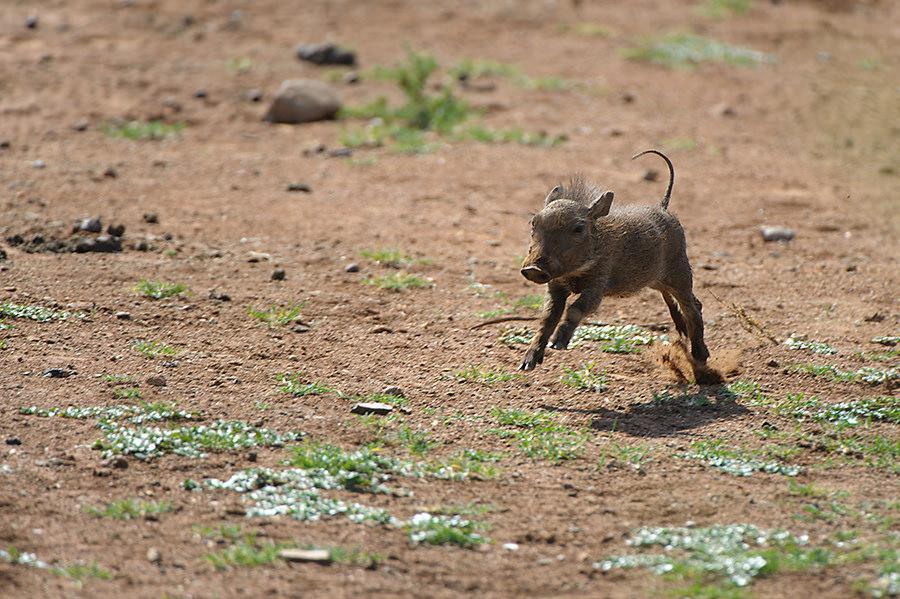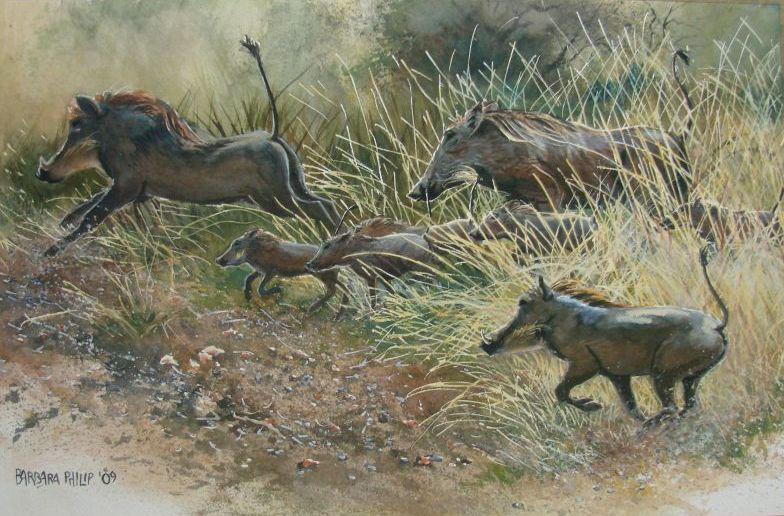The first image is the image on the left, the second image is the image on the right. Examine the images to the left and right. Is the description "There is exactly one animal in the image on the left." accurate? Answer yes or no. Yes. The first image is the image on the left, the second image is the image on the right. Examine the images to the left and right. Is the description "Left image shows one young hog running forward." accurate? Answer yes or no. Yes. 